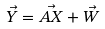Convert formula to latex. <formula><loc_0><loc_0><loc_500><loc_500>\vec { Y } = \vec { A X } + \vec { W }</formula> 